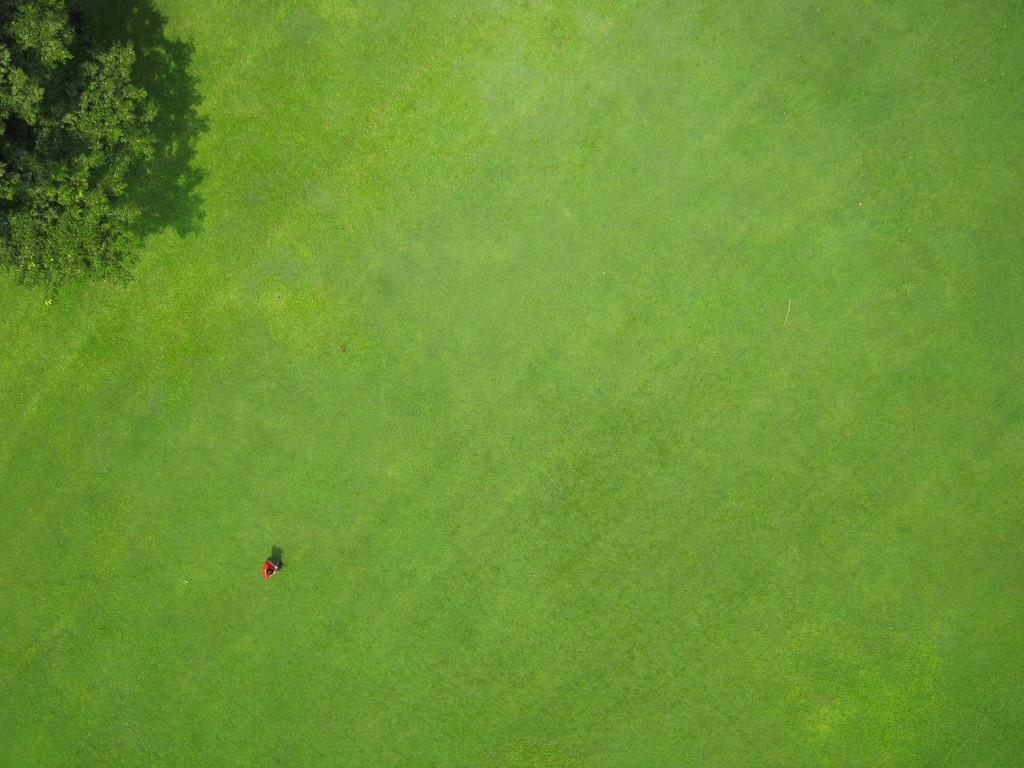What type of view is depicted in the image? The image is an aerial view. Can you describe what is on the ground in the image? There is a person standing on the grassland in the image. What is located on the left side of the image? There is a tree on the left side of the image. What type of pie is being served on the tree in the image? There is no pie present in the image; it features a person standing on the grassland and a tree on the left side. 